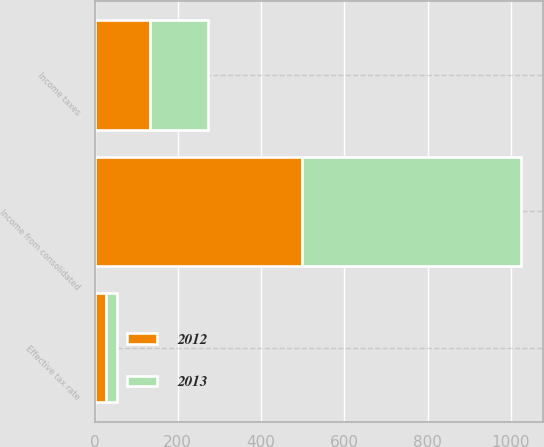Convert chart to OTSL. <chart><loc_0><loc_0><loc_500><loc_500><stacked_bar_chart><ecel><fcel>Income from consolidated<fcel>Income taxes<fcel>Effective tax rate<nl><fcel>2012<fcel>499.4<fcel>133.6<fcel>26.8<nl><fcel>2013<fcel>526.1<fcel>139.8<fcel>26.6<nl></chart> 